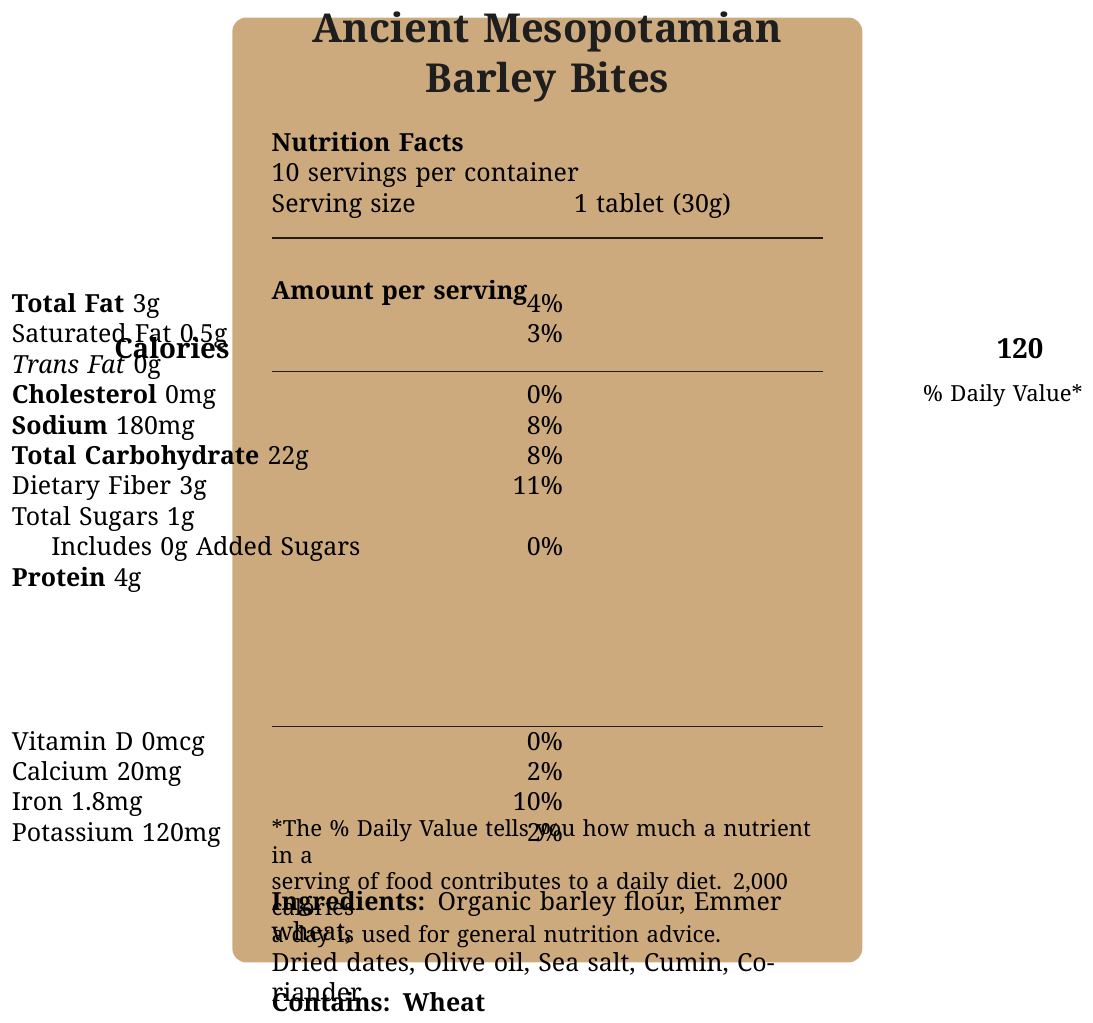what is the serving size? The serving size is stated clearly on the nutrition facts label under "Serving size".
Answer: 1 tablet (30g) how many calories are in one serving? The calorie content per serving is listed as 120 under the heading "Calories".
Answer: 120 what is the total fat content per serving? The total fat content per serving is stated as 3g under "Total Fat".
Answer: 3g which ingredient gives natural sweetness to the snack? The document mentions dried dates as an ingredient providing natural sweetness in the section called "nutritional note".
Answer: Dried dates is the snack product gluten-free? The "Contains: Wheat" section in the allergen information indicates that the product is not gluten-free.
Answer: No how much dietary fiber is in each serving? The dietary fiber content is shown as 3g per serving under "Dietary Fiber".
Answer: 3g how much sodium is in one serving? The sodium content per serving is listed as 180mg in the nutrition facts.
Answer: 180mg what is the daily value percentage of iron per serving? A. 2% B. 8% C. 10% D. 15% The daily value percentage of iron per serving is 10%, as shown under "Iron".
Answer: C what type of oil is used in the product? A. Coconut oil B. Olive oil C. Canola oil D. Vegetable oil Olive oil is listed as one of the ingredients.
Answer: B does the snack contain any added sugars? The document specifies that the snack includes 0g of added sugars under "Includes 0g Added Sugars".
Answer: No summarize the information provided in the document. The document is a comprehensive presentation of the nutrition facts label for "Ancient Mesopotamian Barley Bites", offering nutritional breakdown, historical and artistic significance, and ingredient details.
Answer: The document provides a detailed nutrition facts label for "Ancient Mesopotamian Barley Bites", including servings per container, serving size, calorie count, amounts of various nutrients, and their daily value percentages. It lists the ingredients, allergen information, and several insights about the historical and nutritional context of the product. The packaging design is inspired by ancient Mesopotamian artifacts and the snack aims to replicate the eating habits of ancient civilizations. what is the main source of dietary fiber in the product? The document does not specify a particular source of dietary fiber among the ingredients listed.
Answer: Cannot be determined what is the historical inspiration behind the shape of the snack? The document mentions that the tablet shape of the snack pays homage to cuneiform writing tablets used by ancient Sumerians.
Answer: Cuneiform writing tablets 